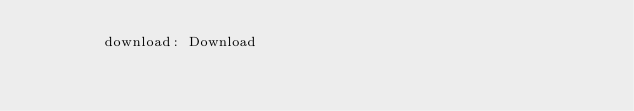<code> <loc_0><loc_0><loc_500><loc_500><_YAML_>        download: Download
</code> 